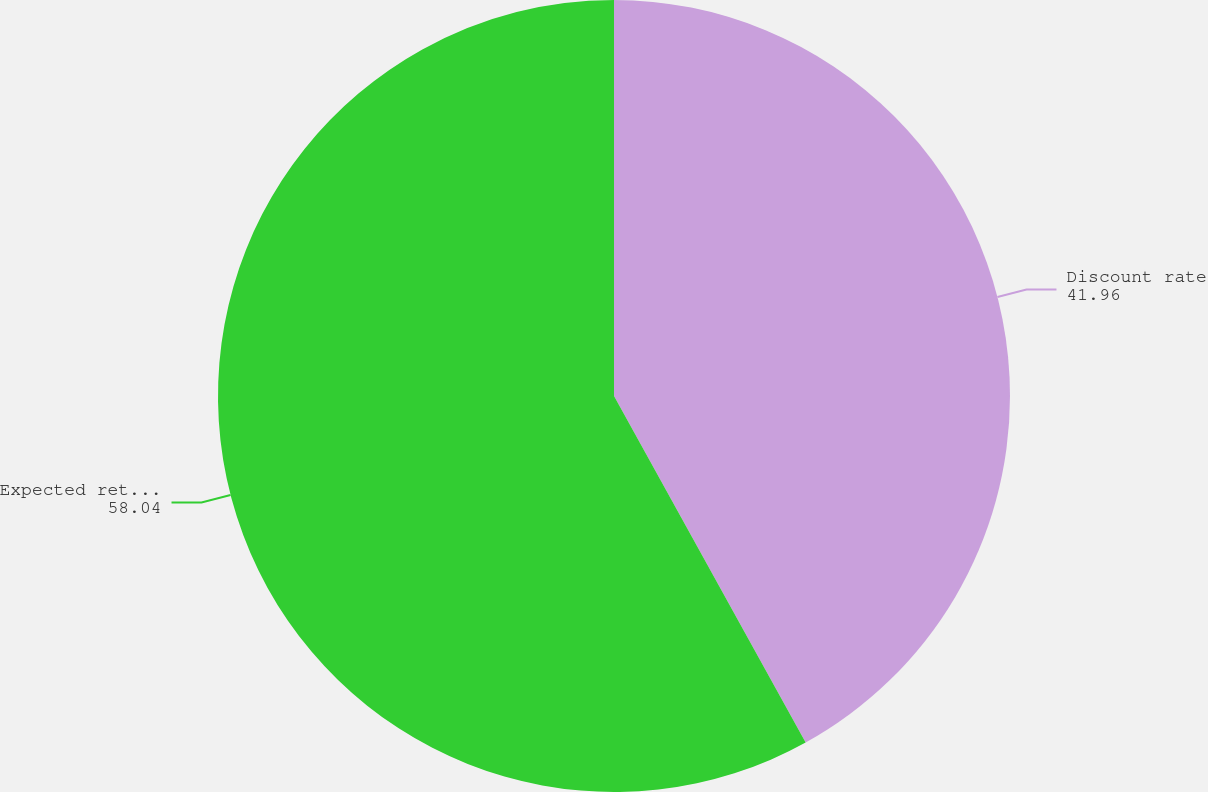Convert chart to OTSL. <chart><loc_0><loc_0><loc_500><loc_500><pie_chart><fcel>Discount rate<fcel>Expected return on plan assets<nl><fcel>41.96%<fcel>58.04%<nl></chart> 